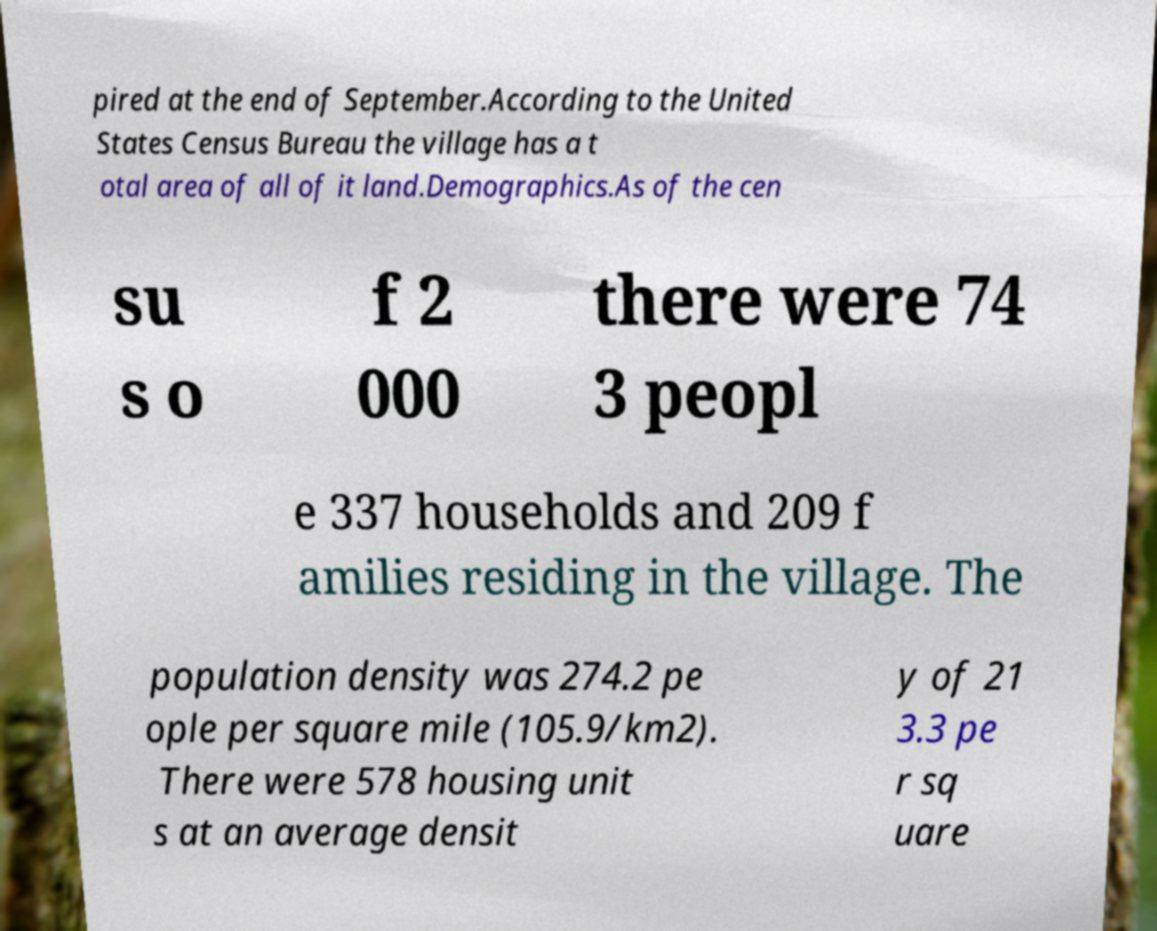What messages or text are displayed in this image? I need them in a readable, typed format. pired at the end of September.According to the United States Census Bureau the village has a t otal area of all of it land.Demographics.As of the cen su s o f 2 000 there were 74 3 peopl e 337 households and 209 f amilies residing in the village. The population density was 274.2 pe ople per square mile (105.9/km2). There were 578 housing unit s at an average densit y of 21 3.3 pe r sq uare 